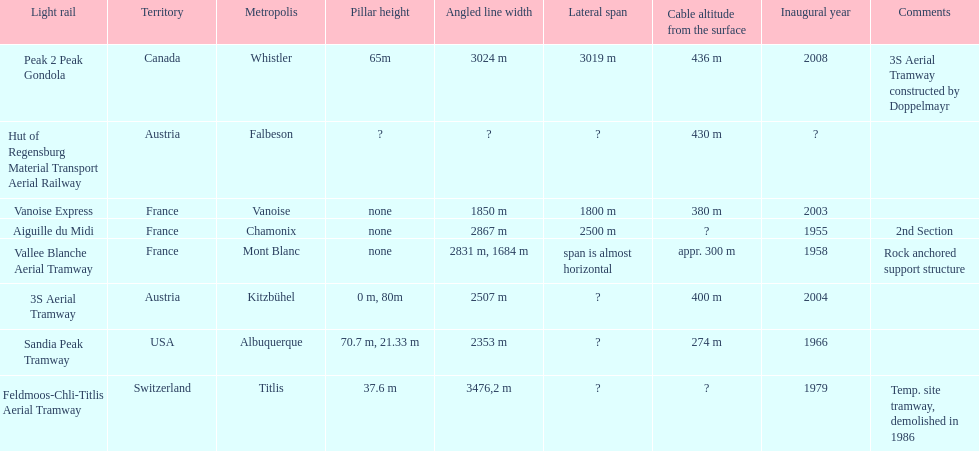Which tramway was inaugurated first, the 3s aerial tramway or the aiguille du midi? Aiguille du Midi. 